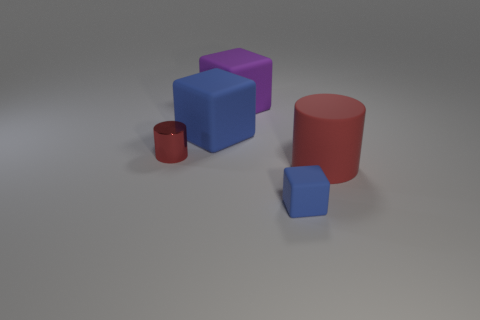There is a large matte object that is the same color as the tiny matte thing; what shape is it?
Ensure brevity in your answer.  Cube. How many objects are either small rubber things or big matte objects in front of the purple rubber object?
Offer a terse response. 3. Do the large object on the left side of the purple thing and the metal object have the same color?
Offer a terse response. No. Is the number of red metal cylinders that are behind the red matte thing greater than the number of things in front of the purple matte thing?
Your answer should be very brief. No. What number of objects are small green metallic objects or large purple matte cubes?
Keep it short and to the point. 1. Is the size of the blue cube that is on the left side of the purple cube the same as the big red object?
Your answer should be compact. Yes. What number of other objects are there of the same size as the red matte object?
Keep it short and to the point. 2. Are any matte cylinders visible?
Ensure brevity in your answer.  Yes. There is a rubber cube behind the blue matte object behind the rubber cylinder; what is its size?
Provide a succinct answer. Large. There is a cylinder that is left of the purple matte cube; does it have the same color as the big object in front of the red shiny thing?
Offer a terse response. Yes. 